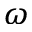Convert formula to latex. <formula><loc_0><loc_0><loc_500><loc_500>\omega</formula> 